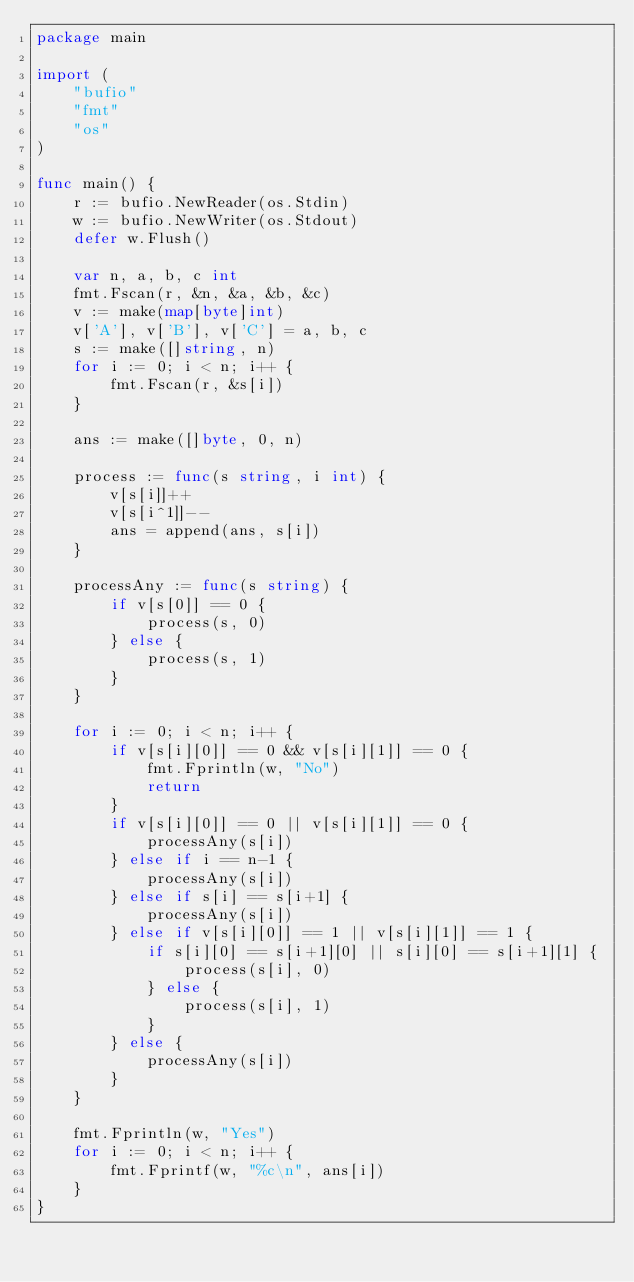Convert code to text. <code><loc_0><loc_0><loc_500><loc_500><_Go_>package main

import (
	"bufio"
	"fmt"
	"os"
)

func main() {
	r := bufio.NewReader(os.Stdin)
	w := bufio.NewWriter(os.Stdout)
	defer w.Flush()

	var n, a, b, c int
	fmt.Fscan(r, &n, &a, &b, &c)
	v := make(map[byte]int)
	v['A'], v['B'], v['C'] = a, b, c
	s := make([]string, n)
	for i := 0; i < n; i++ {
		fmt.Fscan(r, &s[i])
	}

	ans := make([]byte, 0, n)

	process := func(s string, i int) {
		v[s[i]]++
		v[s[i^1]]--
		ans = append(ans, s[i])
	}

	processAny := func(s string) {
		if v[s[0]] == 0 {
			process(s, 0)
		} else {
			process(s, 1)
		}
	}

	for i := 0; i < n; i++ {
		if v[s[i][0]] == 0 && v[s[i][1]] == 0 {
			fmt.Fprintln(w, "No")
			return
		}
		if v[s[i][0]] == 0 || v[s[i][1]] == 0 {
			processAny(s[i])
		} else if i == n-1 {
			processAny(s[i])
		} else if s[i] == s[i+1] {
			processAny(s[i])
		} else if v[s[i][0]] == 1 || v[s[i][1]] == 1 {
			if s[i][0] == s[i+1][0] || s[i][0] == s[i+1][1] {
				process(s[i], 0)
			} else {
				process(s[i], 1)
			}
		} else {
			processAny(s[i])
		}
	}

	fmt.Fprintln(w, "Yes")
	for i := 0; i < n; i++ {
		fmt.Fprintf(w, "%c\n", ans[i])
	}
}
</code> 